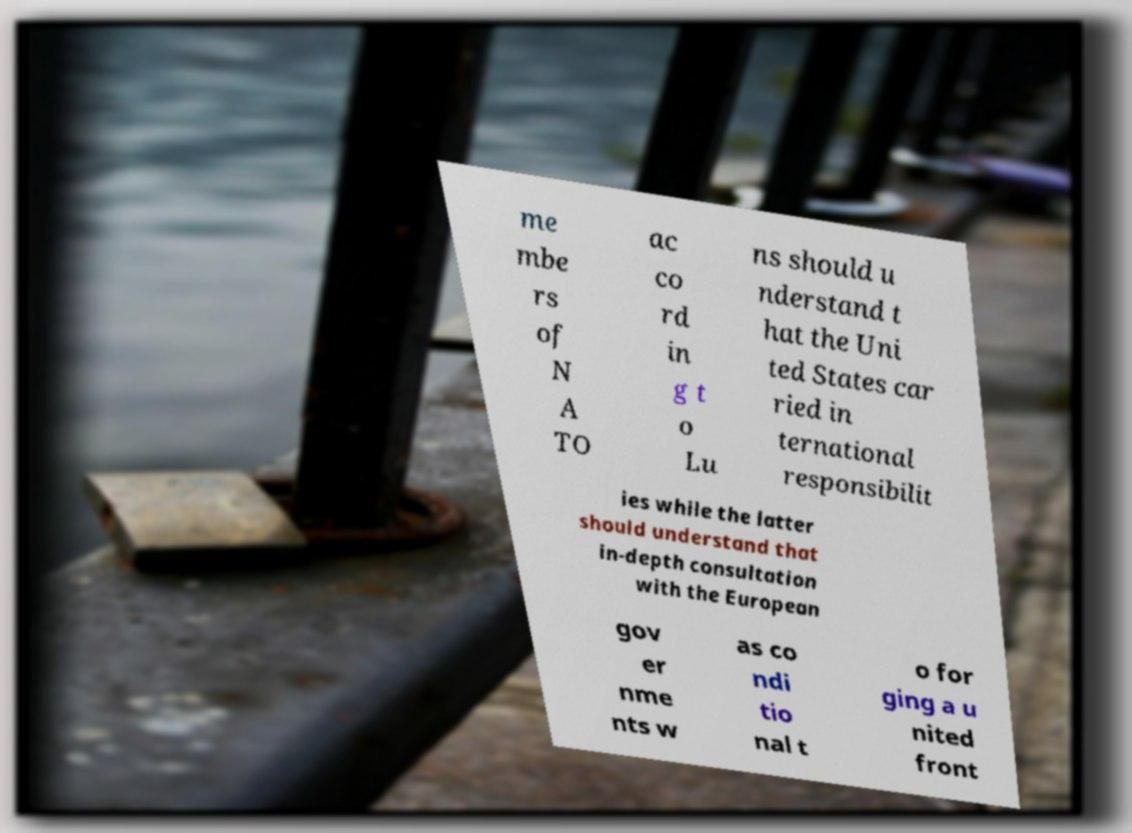For documentation purposes, I need the text within this image transcribed. Could you provide that? me mbe rs of N A TO ac co rd in g t o Lu ns should u nderstand t hat the Uni ted States car ried in ternational responsibilit ies while the latter should understand that in-depth consultation with the European gov er nme nts w as co ndi tio nal t o for ging a u nited front 